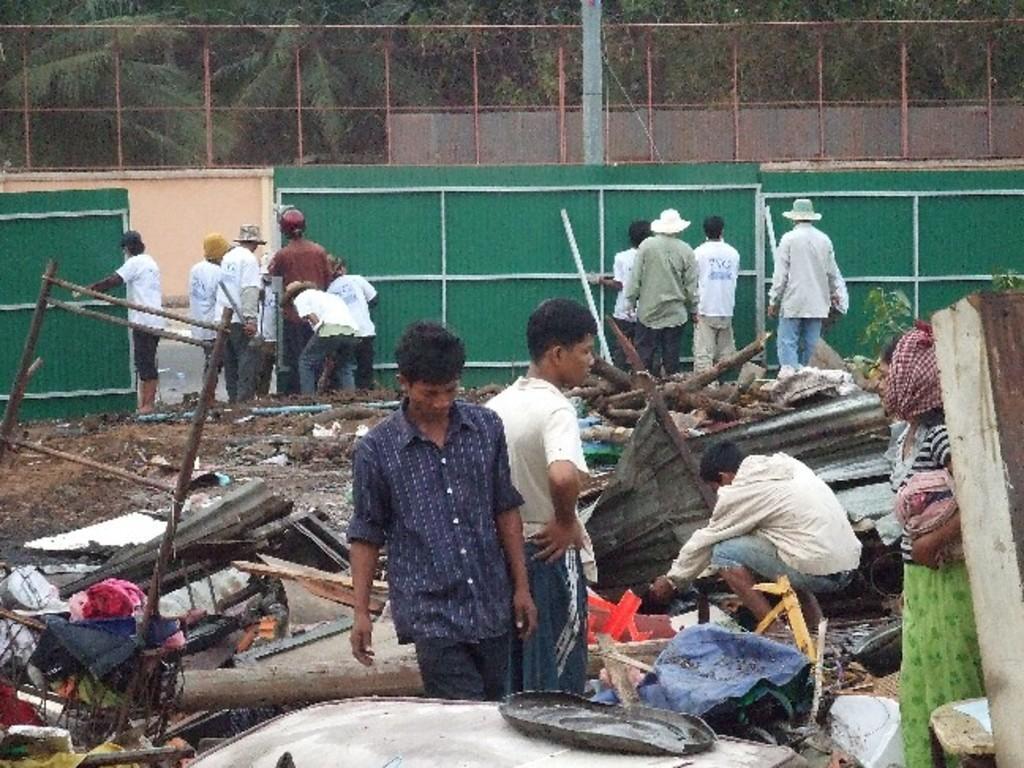Can you describe this image briefly? In this image we can see there are people and objects. There is fencing and trees.   